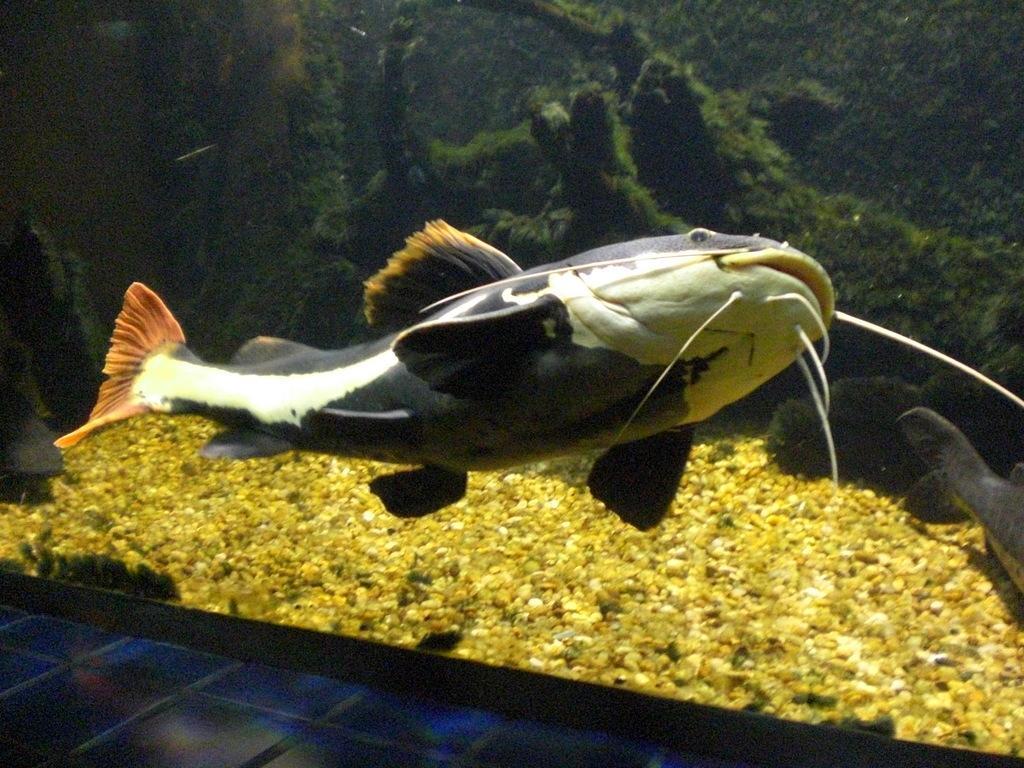Please provide a concise description of this image. In this picture there is a big fish in the center of the image and there is another fish on the right side of the image, there are pebbles and plants inside the aquarium. 